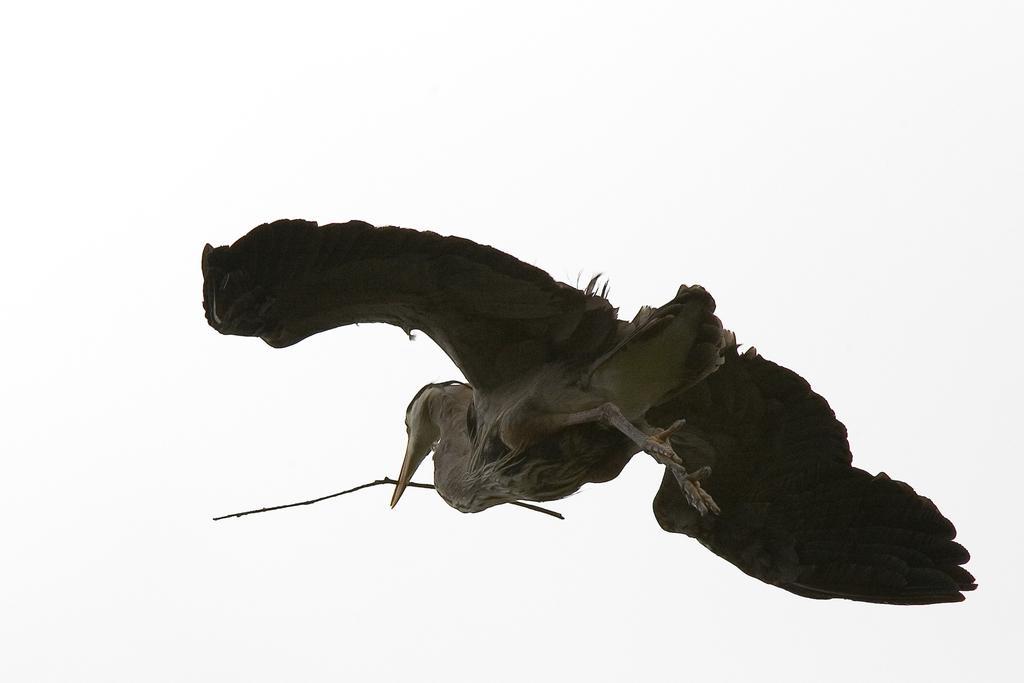In one or two sentences, can you explain what this image depicts? In this image I can see a bird which is black and cream in color is flying in the air and holding a stick in its mouth and I can see the white colored background. 